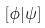<formula> <loc_0><loc_0><loc_500><loc_500>[ \phi { | } \psi ]</formula> 